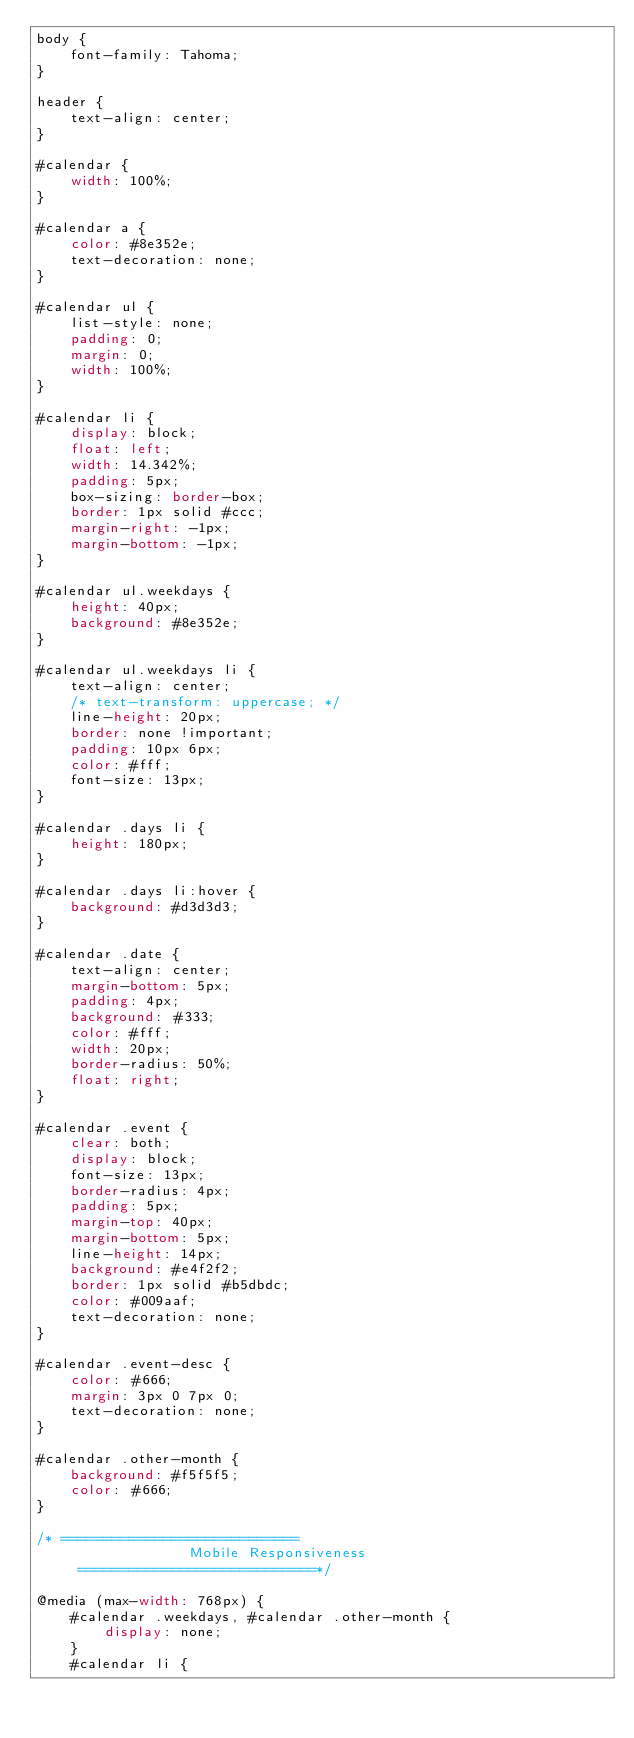Convert code to text. <code><loc_0><loc_0><loc_500><loc_500><_CSS_>body {
    font-family: Tahoma;
}

header {
    text-align: center;
}

#calendar {
    width: 100%;
}

#calendar a {
    color: #8e352e;
    text-decoration: none;
}

#calendar ul {
    list-style: none;
    padding: 0;
    margin: 0;
    width: 100%;
}

#calendar li {
    display: block;
    float: left;
    width: 14.342%;
    padding: 5px;
    box-sizing: border-box;
    border: 1px solid #ccc;
    margin-right: -1px;
    margin-bottom: -1px;
}

#calendar ul.weekdays {
    height: 40px;
    background: #8e352e;
}

#calendar ul.weekdays li {
    text-align: center;
    /* text-transform: uppercase; */
    line-height: 20px;
    border: none !important;
    padding: 10px 6px;
    color: #fff;
    font-size: 13px;
}

#calendar .days li {
    height: 180px;
}

#calendar .days li:hover {
    background: #d3d3d3;
}

#calendar .date {
    text-align: center;
    margin-bottom: 5px;
    padding: 4px;
    background: #333;
    color: #fff;
    width: 20px;
    border-radius: 50%;
    float: right;
}

#calendar .event {
    clear: both;
    display: block;
    font-size: 13px;
    border-radius: 4px;
    padding: 5px;
    margin-top: 40px;
    margin-bottom: 5px;
    line-height: 14px;
    background: #e4f2f2;
    border: 1px solid #b5dbdc;
    color: #009aaf;
    text-decoration: none;
}

#calendar .event-desc {
    color: #666;
    margin: 3px 0 7px 0;
    text-decoration: none;
}

#calendar .other-month {
    background: #f5f5f5;
    color: #666;
}

/* ============================
                  Mobile Responsiveness
     ============================*/

@media (max-width: 768px) {
    #calendar .weekdays, #calendar .other-month {
        display: none;
    }
    #calendar li {</code> 